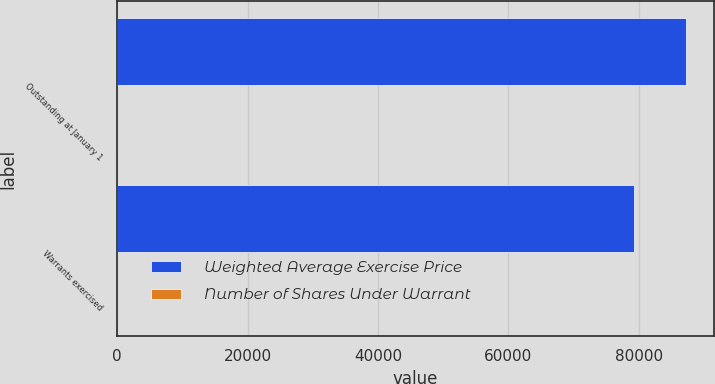<chart> <loc_0><loc_0><loc_500><loc_500><stacked_bar_chart><ecel><fcel>Outstanding at January 1<fcel>Warrants exercised<nl><fcel>Weighted Average Exercise Price<fcel>87149<fcel>79306<nl><fcel>Number of Shares Under Warrant<fcel>13.24<fcel>12.84<nl></chart> 